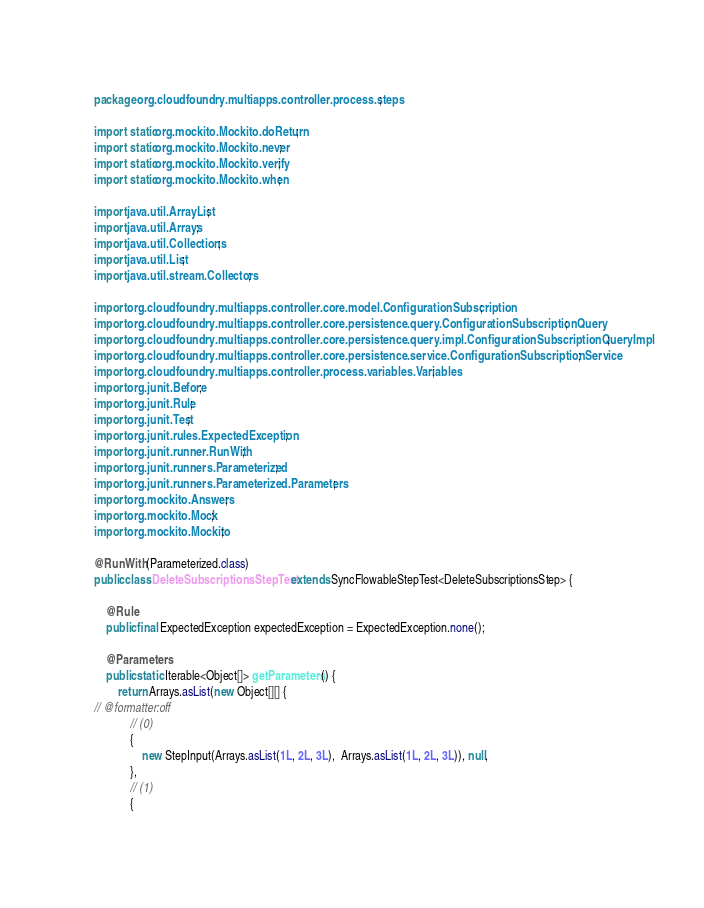Convert code to text. <code><loc_0><loc_0><loc_500><loc_500><_Java_>package org.cloudfoundry.multiapps.controller.process.steps;

import static org.mockito.Mockito.doReturn;
import static org.mockito.Mockito.never;
import static org.mockito.Mockito.verify;
import static org.mockito.Mockito.when;

import java.util.ArrayList;
import java.util.Arrays;
import java.util.Collections;
import java.util.List;
import java.util.stream.Collectors;

import org.cloudfoundry.multiapps.controller.core.model.ConfigurationSubscription;
import org.cloudfoundry.multiapps.controller.core.persistence.query.ConfigurationSubscriptionQuery;
import org.cloudfoundry.multiapps.controller.core.persistence.query.impl.ConfigurationSubscriptionQueryImpl;
import org.cloudfoundry.multiapps.controller.core.persistence.service.ConfigurationSubscriptionService;
import org.cloudfoundry.multiapps.controller.process.variables.Variables;
import org.junit.Before;
import org.junit.Rule;
import org.junit.Test;
import org.junit.rules.ExpectedException;
import org.junit.runner.RunWith;
import org.junit.runners.Parameterized;
import org.junit.runners.Parameterized.Parameters;
import org.mockito.Answers;
import org.mockito.Mock;
import org.mockito.Mockito;

@RunWith(Parameterized.class)
public class DeleteSubscriptionsStepTest extends SyncFlowableStepTest<DeleteSubscriptionsStep> {

    @Rule
    public final ExpectedException expectedException = ExpectedException.none();

    @Parameters
    public static Iterable<Object[]> getParameters() {
        return Arrays.asList(new Object[][] {
// @formatter:off
            // (0)
            {
                new StepInput(Arrays.asList(1L, 2L, 3L),  Arrays.asList(1L, 2L, 3L)), null,
            },
            // (1)
            {</code> 